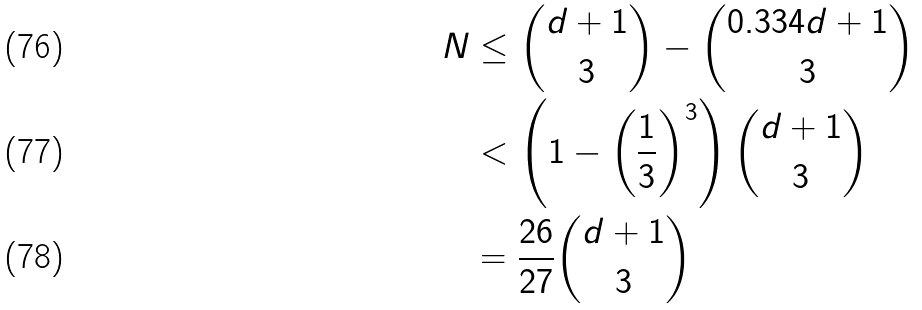<formula> <loc_0><loc_0><loc_500><loc_500>N & \leq \binom { d + 1 } { 3 } - \binom { 0 . 3 3 4 d + 1 } { 3 } \\ & < \left ( 1 - \left ( \frac { 1 } { 3 } \right ) ^ { 3 } \right ) \binom { d + 1 } { 3 } \\ & = \frac { 2 6 } { 2 7 } \binom { d + 1 } { 3 }</formula> 